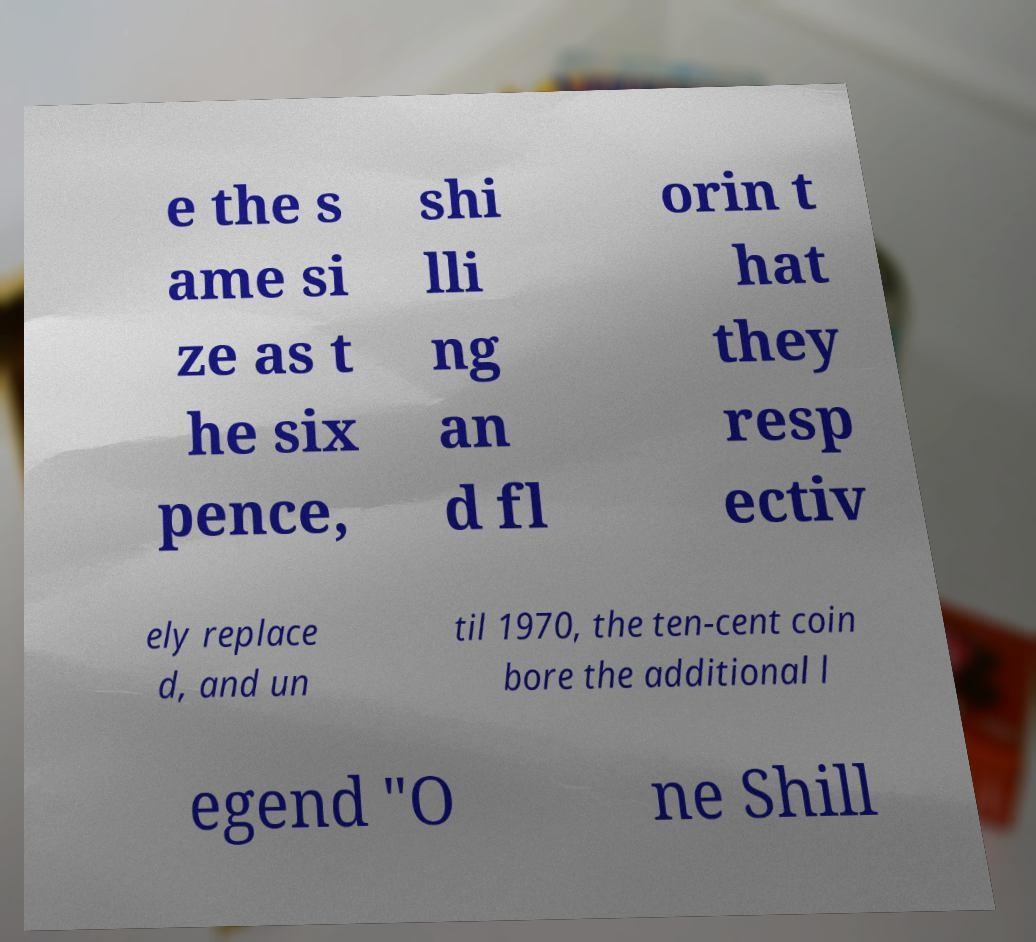For documentation purposes, I need the text within this image transcribed. Could you provide that? e the s ame si ze as t he six pence, shi lli ng an d fl orin t hat they resp ectiv ely replace d, and un til 1970, the ten-cent coin bore the additional l egend "O ne Shill 